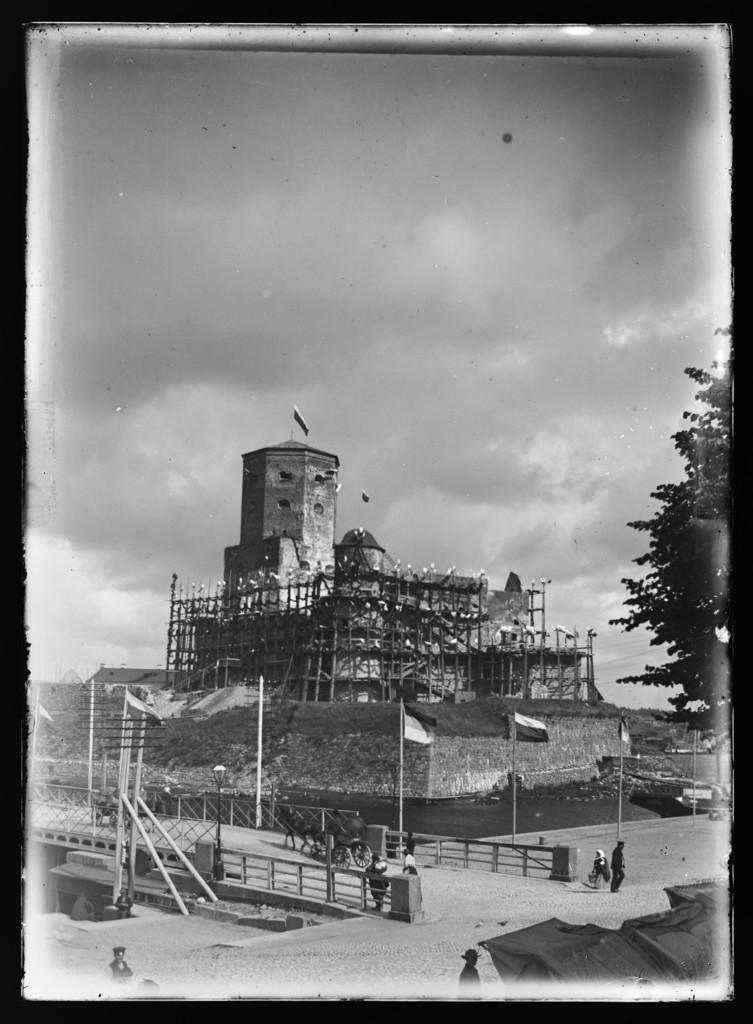Can you describe this image briefly? This is a black and white image. There is a bridge at the center and there are flags. People are present near it. There is a tree at the right corner. There is water beside the bridge. There is a building at the back and there are flags on the top of it. There is sky on the top. 